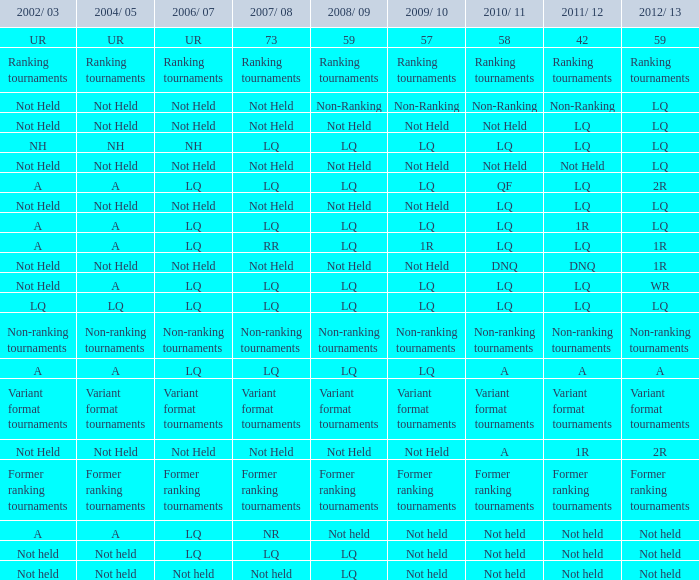What are the 2009/10 and 2011/12 instances of lq and the 2008/09 instance that was not held? Not Held, Not Held. 